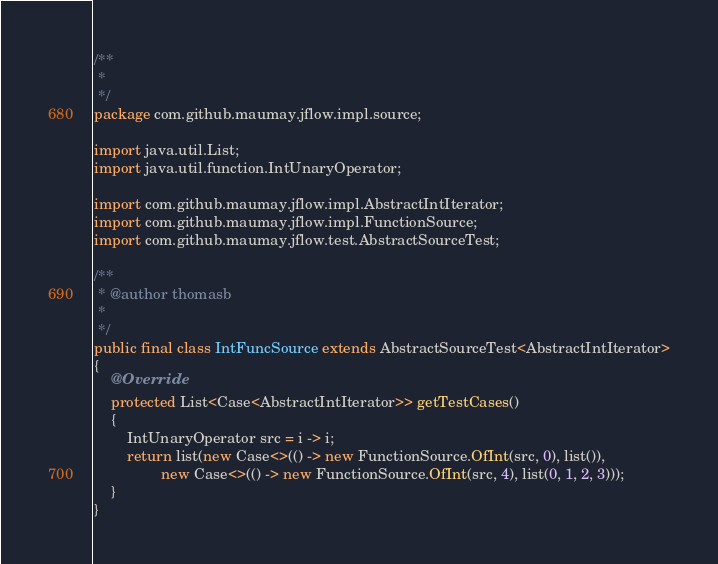Convert code to text. <code><loc_0><loc_0><loc_500><loc_500><_Java_>/**
 * 
 */
package com.github.maumay.jflow.impl.source;

import java.util.List;
import java.util.function.IntUnaryOperator;

import com.github.maumay.jflow.impl.AbstractIntIterator;
import com.github.maumay.jflow.impl.FunctionSource;
import com.github.maumay.jflow.test.AbstractSourceTest;

/**
 * @author thomasb
 *
 */
public final class IntFuncSource extends AbstractSourceTest<AbstractIntIterator>
{
	@Override
	protected List<Case<AbstractIntIterator>> getTestCases()
	{
		IntUnaryOperator src = i -> i;
		return list(new Case<>(() -> new FunctionSource.OfInt(src, 0), list()),
				new Case<>(() -> new FunctionSource.OfInt(src, 4), list(0, 1, 2, 3)));
	}
}
</code> 